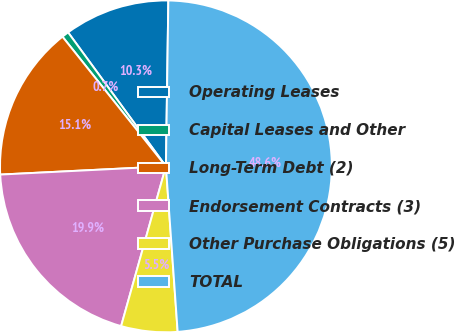Convert chart to OTSL. <chart><loc_0><loc_0><loc_500><loc_500><pie_chart><fcel>Operating Leases<fcel>Capital Leases and Other<fcel>Long-Term Debt (2)<fcel>Endorsement Contracts (3)<fcel>Other Purchase Obligations (5)<fcel>TOTAL<nl><fcel>10.27%<fcel>0.68%<fcel>15.07%<fcel>19.86%<fcel>5.48%<fcel>48.64%<nl></chart> 